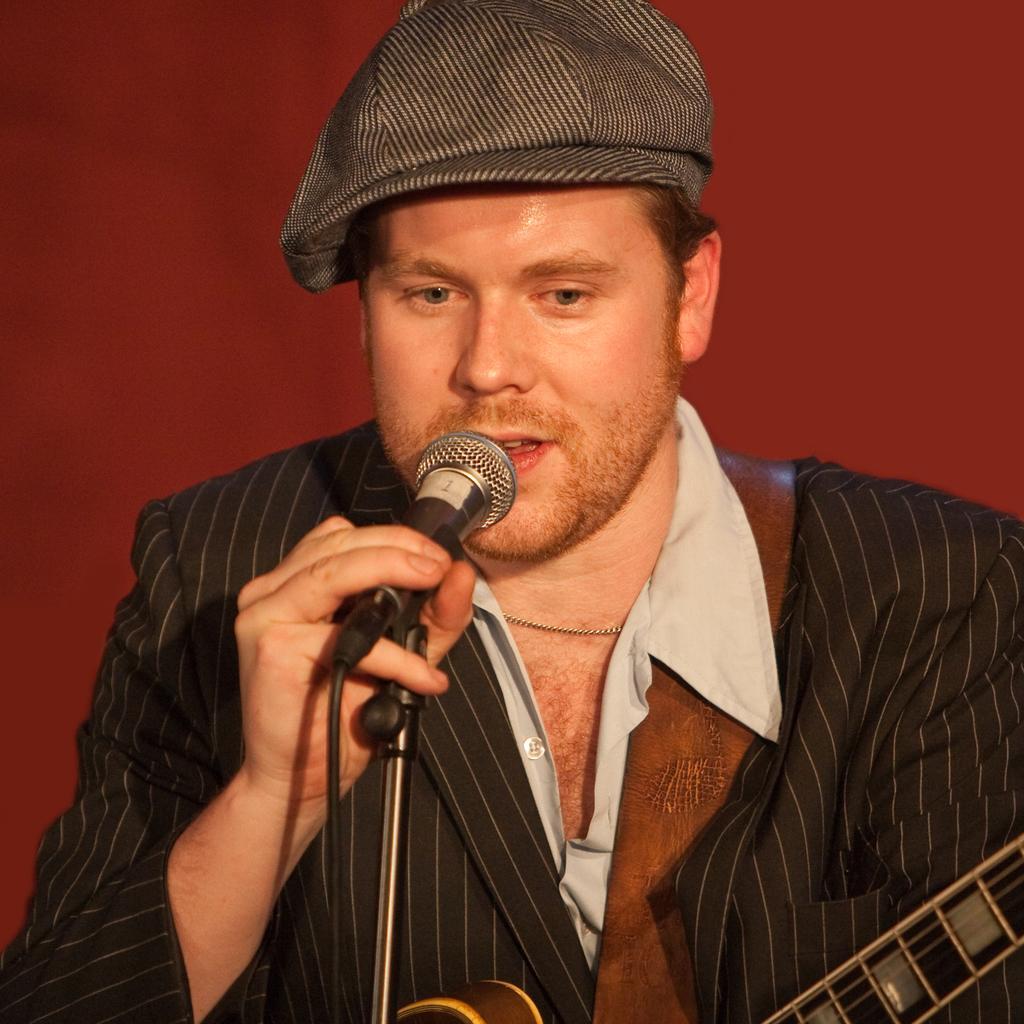Please provide a concise description of this image. This image consists of a man who is wearing black dress. He is holding a mic in his hand. He is singing something, he has a musical instrument in his other hand. 